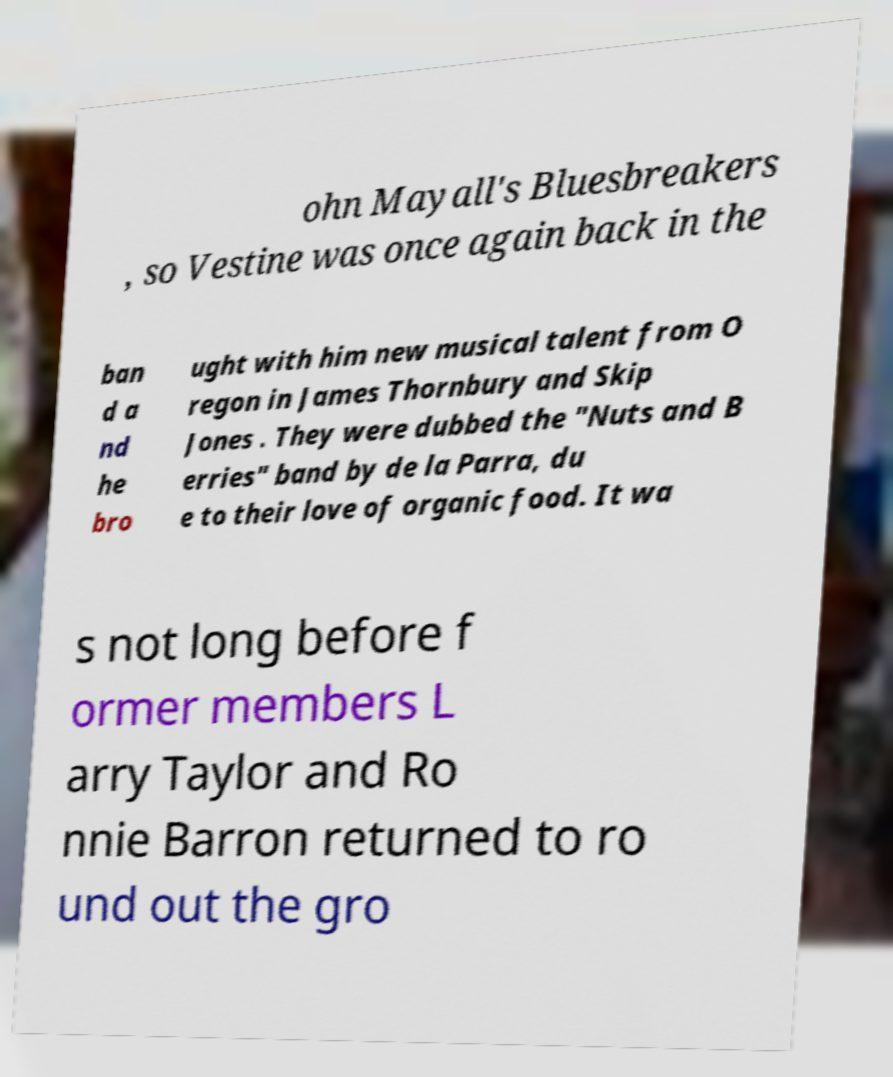Can you accurately transcribe the text from the provided image for me? ohn Mayall's Bluesbreakers , so Vestine was once again back in the ban d a nd he bro ught with him new musical talent from O regon in James Thornbury and Skip Jones . They were dubbed the "Nuts and B erries" band by de la Parra, du e to their love of organic food. It wa s not long before f ormer members L arry Taylor and Ro nnie Barron returned to ro und out the gro 